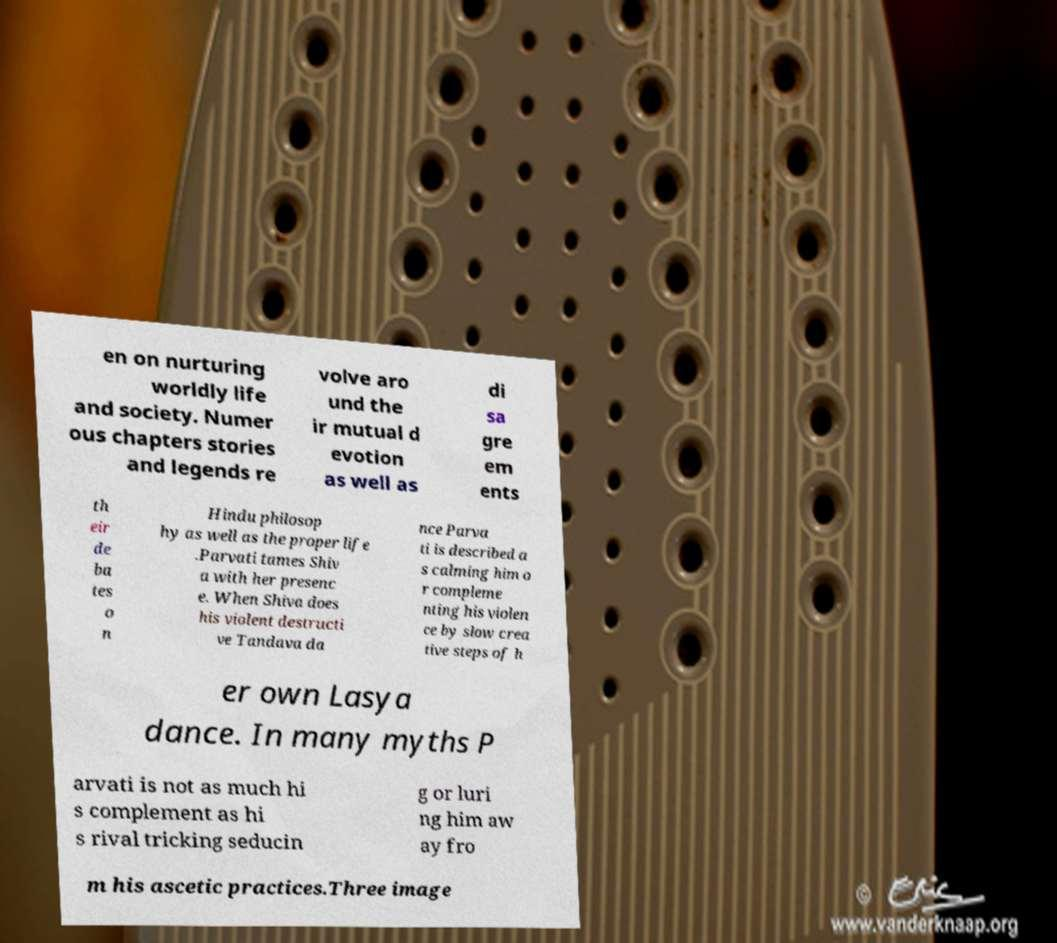I need the written content from this picture converted into text. Can you do that? en on nurturing worldly life and society. Numer ous chapters stories and legends re volve aro und the ir mutual d evotion as well as di sa gre em ents th eir de ba tes o n Hindu philosop hy as well as the proper life .Parvati tames Shiv a with her presenc e. When Shiva does his violent destructi ve Tandava da nce Parva ti is described a s calming him o r compleme nting his violen ce by slow crea tive steps of h er own Lasya dance. In many myths P arvati is not as much hi s complement as hi s rival tricking seducin g or luri ng him aw ay fro m his ascetic practices.Three image 